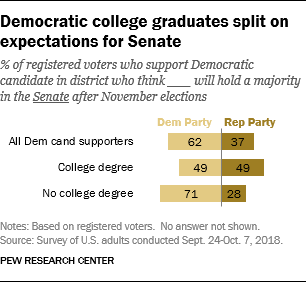Indicate a few pertinent items in this graphic. The average value of the DEM Party is 60.67 and higher. The color that represents the Republican Party is brown. 